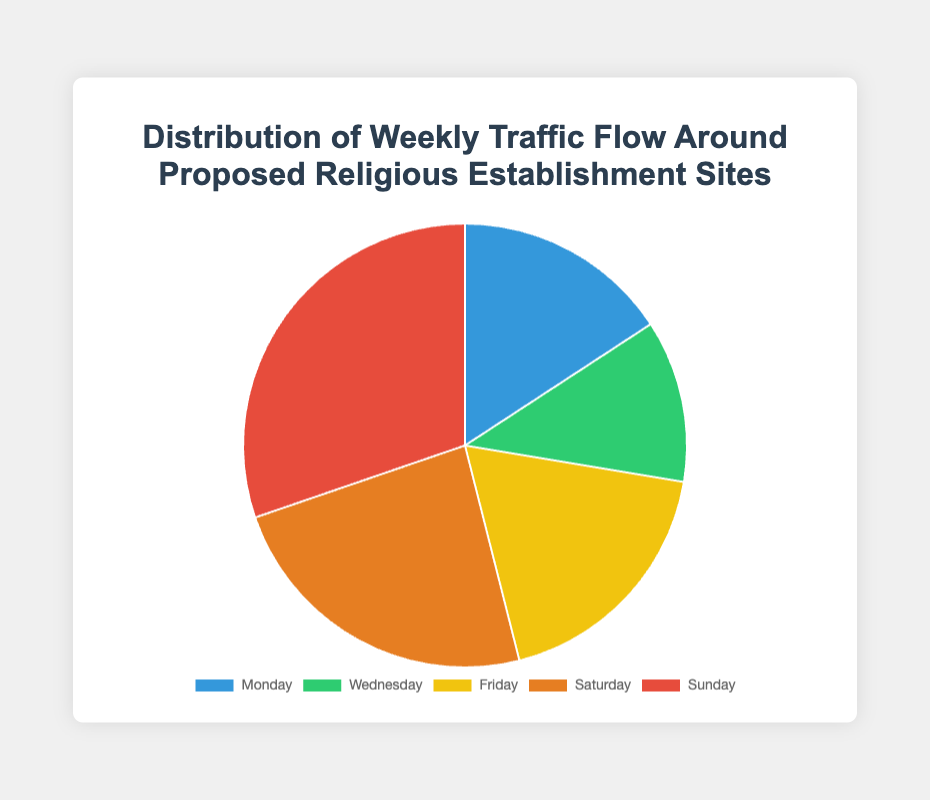How is the traffic flow distributed throughout the week? The chart shows the distribution of weekly traffic flows, represented by segments corresponding to different days from Monday to Sunday.
Answer: It varies by day, with Sunday having the highest flow and Wednesday the lowest Which day has the highest traffic flow? By referring to the size of the pie segments, the segment for Sunday is the largest, indicating the highest traffic flow.
Answer: Sunday Calculate the combined traffic flow for Friday and Saturday. The traffic flow on Friday is 1400, and on Saturday, it is 1800. Adding these two values gives 3200 vehicles.
Answer: 3200 Which day has a higher traffic flow: Monday or Wednesday? By comparing the sizes of the pie segments, Monday’s segment is larger than Wednesday’s.
Answer: Monday What percentage of the weekly traffic does Sunday represent? Sum all traffic flows (1200 + 900 + 1400 + 1800 + 2300 = 7600). Sunday’s traffic is 2300. Divide 2300 by 7600 and multiply by 100 to get the percentage. (2300/7600) * 100 ≈ 30.26%
Answer: 30.26% If we combine the traffic flows of Monday and Wednesday, will it be greater than Sunday’s traffic flow? Monday’s traffic flow is 1200, and Wednesday’s is 900. Adding them gives 2100, which is less than Sunday’s 2300.
Answer: No What is the difference in traffic flow between the day with the highest traffic and the day with the lowest traffic? Sunday has the highest traffic at 2300 vehicles, and Wednesday has the lowest at 900 vehicles. The difference is 2300 - 900 = 1400 vehicles.
Answer: 1400 Compare the traffic flow on Friday to the total traffic for Monday and Wednesday combined. Which one is greater? Friday’s traffic flow is 1400. The combined traffic for Monday and Wednesday is 1200 + 900 = 2100, which is greater than 1400.
Answer: Monday and Wednesday combined Which two consecutive days have the highest combined traffic flow? Checking all pairs: Monday + Wednesday = 2100, Wednesday + Friday = 2300, Friday + Saturday = 3200, Saturday + Sunday = 4100. Saturday and Sunday have the highest combined traffic flow of 4100.
Answer: Saturday and Sunday Find the average traffic flow for the week. Sum all traffic flows (1200 + 900 + 1400 + 1800 + 2300 = 7600). Divide by the number of days (5) to find the average: 7600/5 = 1520.
Answer: 1520 